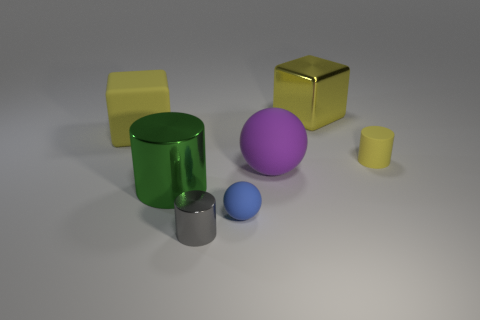Are there the same number of blocks in front of the small sphere and small blue rubber spheres that are on the right side of the big purple matte object?
Offer a terse response. Yes. What is the material of the big purple thing that is the same shape as the small blue matte object?
Your answer should be very brief. Rubber. Are there any large purple matte objects on the left side of the tiny cylinder that is in front of the tiny matte thing that is left of the yellow matte cylinder?
Offer a very short reply. No. There is a big matte thing to the left of the green object; is it the same shape as the rubber thing that is to the right of the yellow metallic cube?
Provide a succinct answer. No. Is the number of yellow metal cubes in front of the green shiny thing greater than the number of tiny gray cylinders?
Your answer should be very brief. No. What number of things are big yellow matte objects or big matte things?
Provide a short and direct response. 2. What is the color of the big cylinder?
Offer a very short reply. Green. How many other things are there of the same color as the big shiny cube?
Offer a very short reply. 2. There is a green metallic thing; are there any metal cubes to the left of it?
Offer a terse response. No. What color is the large block that is on the left side of the block that is behind the yellow cube that is left of the small gray object?
Make the answer very short. Yellow. 